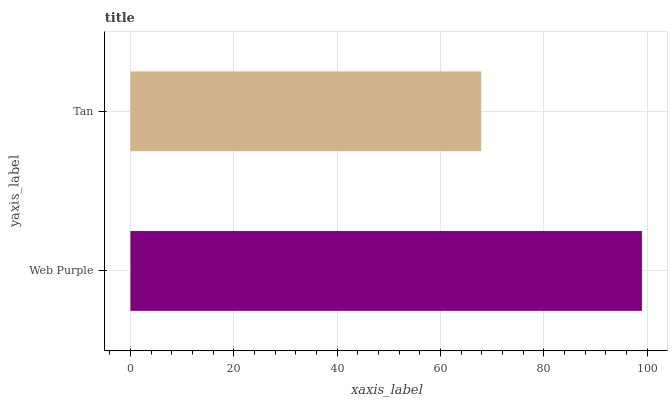Is Tan the minimum?
Answer yes or no. Yes. Is Web Purple the maximum?
Answer yes or no. Yes. Is Tan the maximum?
Answer yes or no. No. Is Web Purple greater than Tan?
Answer yes or no. Yes. Is Tan less than Web Purple?
Answer yes or no. Yes. Is Tan greater than Web Purple?
Answer yes or no. No. Is Web Purple less than Tan?
Answer yes or no. No. Is Web Purple the high median?
Answer yes or no. Yes. Is Tan the low median?
Answer yes or no. Yes. Is Tan the high median?
Answer yes or no. No. Is Web Purple the low median?
Answer yes or no. No. 